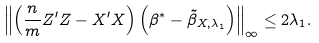Convert formula to latex. <formula><loc_0><loc_0><loc_500><loc_500>\left \| \left ( \frac { n } { m } Z ^ { \prime } Z - X ^ { \prime } X \right ) \left ( \beta ^ { * } - \tilde { \beta } _ { X , \lambda _ { 1 } } \right ) \right \| _ { \infty } \leq 2 \lambda _ { 1 } .</formula> 